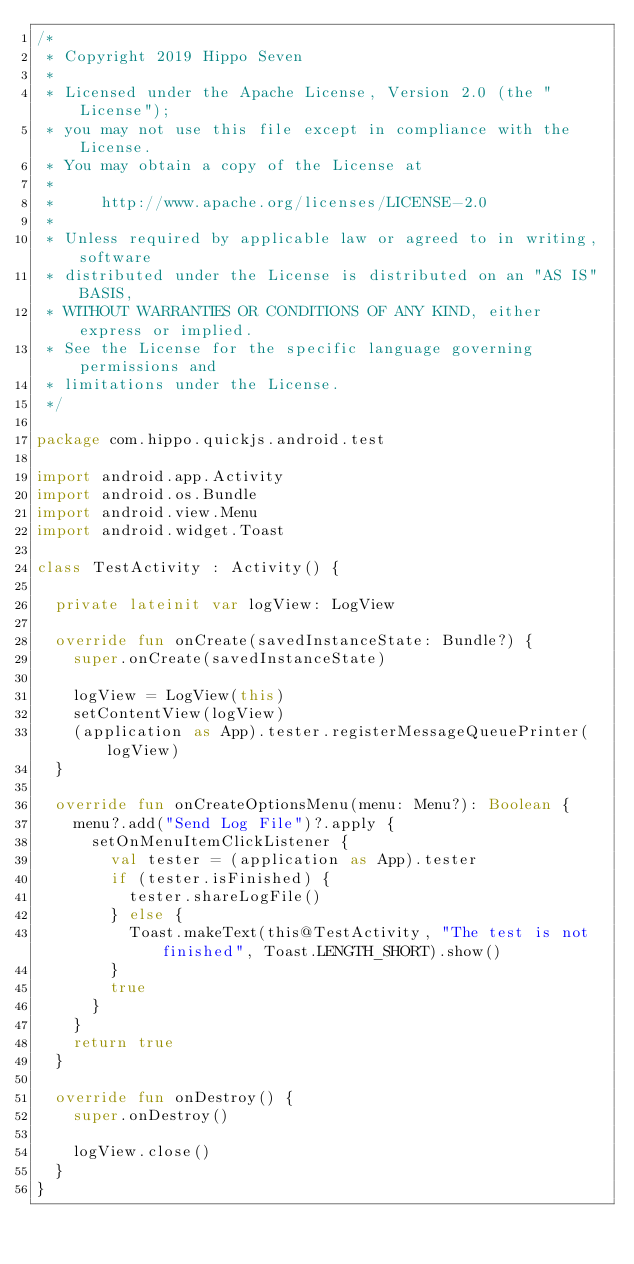<code> <loc_0><loc_0><loc_500><loc_500><_Kotlin_>/*
 * Copyright 2019 Hippo Seven
 *
 * Licensed under the Apache License, Version 2.0 (the "License");
 * you may not use this file except in compliance with the License.
 * You may obtain a copy of the License at
 *
 *     http://www.apache.org/licenses/LICENSE-2.0
 *
 * Unless required by applicable law or agreed to in writing, software
 * distributed under the License is distributed on an "AS IS" BASIS,
 * WITHOUT WARRANTIES OR CONDITIONS OF ANY KIND, either express or implied.
 * See the License for the specific language governing permissions and
 * limitations under the License.
 */

package com.hippo.quickjs.android.test

import android.app.Activity
import android.os.Bundle
import android.view.Menu
import android.widget.Toast

class TestActivity : Activity() {

  private lateinit var logView: LogView

  override fun onCreate(savedInstanceState: Bundle?) {
    super.onCreate(savedInstanceState)

    logView = LogView(this)
    setContentView(logView)
    (application as App).tester.registerMessageQueuePrinter(logView)
  }

  override fun onCreateOptionsMenu(menu: Menu?): Boolean {
    menu?.add("Send Log File")?.apply {
      setOnMenuItemClickListener {
        val tester = (application as App).tester
        if (tester.isFinished) {
          tester.shareLogFile()
        } else {
          Toast.makeText(this@TestActivity, "The test is not finished", Toast.LENGTH_SHORT).show()
        }
        true
      }
    }
    return true
  }

  override fun onDestroy() {
    super.onDestroy()

    logView.close()
  }
}
</code> 